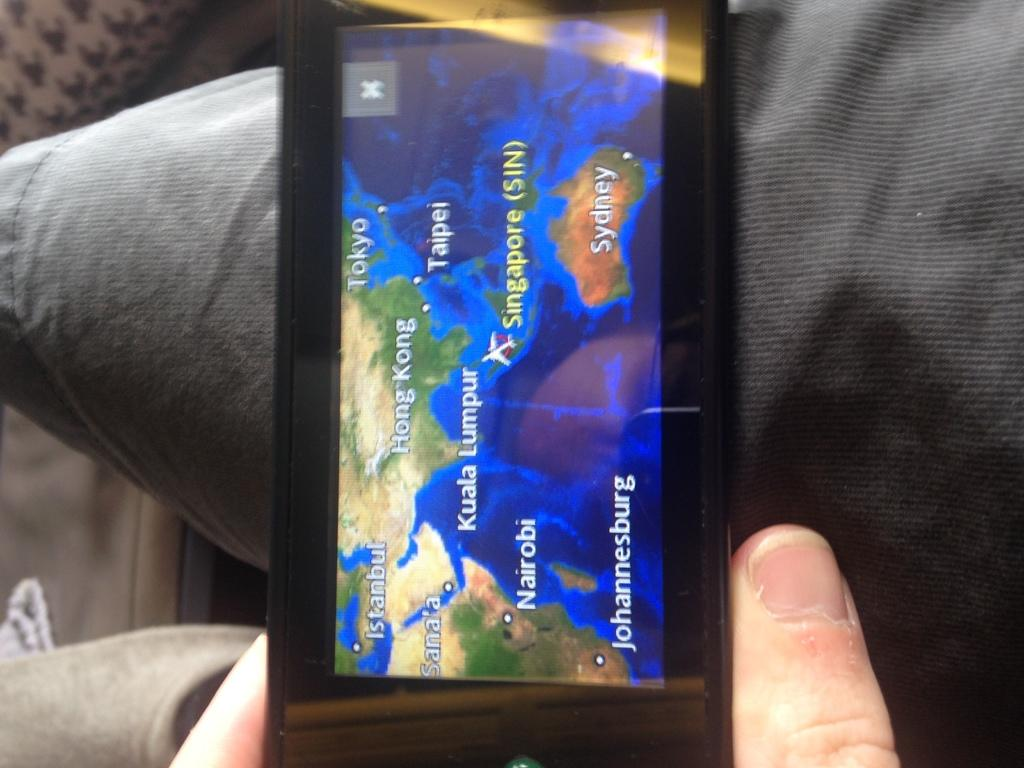<image>
Share a concise interpretation of the image provided. Someone is holding a screen showing that the plane is near Singapore 